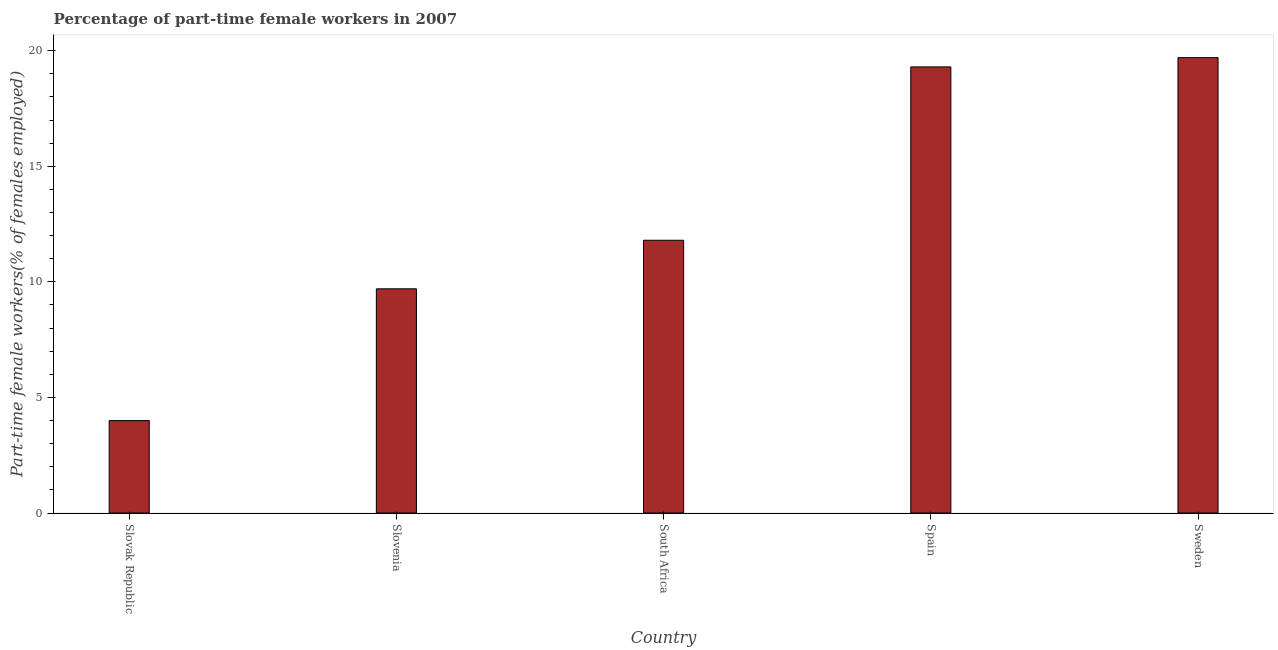Does the graph contain any zero values?
Offer a terse response. No. What is the title of the graph?
Give a very brief answer. Percentage of part-time female workers in 2007. What is the label or title of the X-axis?
Provide a short and direct response. Country. What is the label or title of the Y-axis?
Offer a terse response. Part-time female workers(% of females employed). What is the percentage of part-time female workers in Slovenia?
Your response must be concise. 9.7. Across all countries, what is the maximum percentage of part-time female workers?
Your answer should be very brief. 19.7. In which country was the percentage of part-time female workers minimum?
Provide a short and direct response. Slovak Republic. What is the sum of the percentage of part-time female workers?
Ensure brevity in your answer.  64.5. What is the difference between the percentage of part-time female workers in Slovenia and Sweden?
Ensure brevity in your answer.  -10. What is the median percentage of part-time female workers?
Ensure brevity in your answer.  11.8. What is the ratio of the percentage of part-time female workers in Slovak Republic to that in South Africa?
Your response must be concise. 0.34. Is the difference between the percentage of part-time female workers in Slovenia and Sweden greater than the difference between any two countries?
Give a very brief answer. No. What is the difference between the highest and the second highest percentage of part-time female workers?
Your response must be concise. 0.4. In how many countries, is the percentage of part-time female workers greater than the average percentage of part-time female workers taken over all countries?
Provide a short and direct response. 2. How many bars are there?
Make the answer very short. 5. How many countries are there in the graph?
Your answer should be very brief. 5. What is the Part-time female workers(% of females employed) in Slovenia?
Offer a very short reply. 9.7. What is the Part-time female workers(% of females employed) in South Africa?
Ensure brevity in your answer.  11.8. What is the Part-time female workers(% of females employed) of Spain?
Your response must be concise. 19.3. What is the Part-time female workers(% of females employed) of Sweden?
Provide a short and direct response. 19.7. What is the difference between the Part-time female workers(% of females employed) in Slovak Republic and Slovenia?
Provide a short and direct response. -5.7. What is the difference between the Part-time female workers(% of females employed) in Slovak Republic and South Africa?
Your answer should be very brief. -7.8. What is the difference between the Part-time female workers(% of females employed) in Slovak Republic and Spain?
Make the answer very short. -15.3. What is the difference between the Part-time female workers(% of females employed) in Slovak Republic and Sweden?
Offer a terse response. -15.7. What is the ratio of the Part-time female workers(% of females employed) in Slovak Republic to that in Slovenia?
Your response must be concise. 0.41. What is the ratio of the Part-time female workers(% of females employed) in Slovak Republic to that in South Africa?
Your response must be concise. 0.34. What is the ratio of the Part-time female workers(% of females employed) in Slovak Republic to that in Spain?
Make the answer very short. 0.21. What is the ratio of the Part-time female workers(% of females employed) in Slovak Republic to that in Sweden?
Make the answer very short. 0.2. What is the ratio of the Part-time female workers(% of females employed) in Slovenia to that in South Africa?
Give a very brief answer. 0.82. What is the ratio of the Part-time female workers(% of females employed) in Slovenia to that in Spain?
Your response must be concise. 0.5. What is the ratio of the Part-time female workers(% of females employed) in Slovenia to that in Sweden?
Offer a very short reply. 0.49. What is the ratio of the Part-time female workers(% of females employed) in South Africa to that in Spain?
Offer a very short reply. 0.61. What is the ratio of the Part-time female workers(% of females employed) in South Africa to that in Sweden?
Offer a terse response. 0.6. 